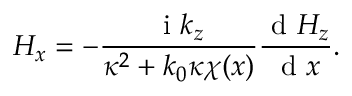<formula> <loc_0><loc_0><loc_500><loc_500>H _ { x } = - \frac { i k _ { z } } { \kappa ^ { 2 } + k _ { 0 } \kappa \chi ( x ) } \frac { d H _ { z } } { d x } .</formula> 